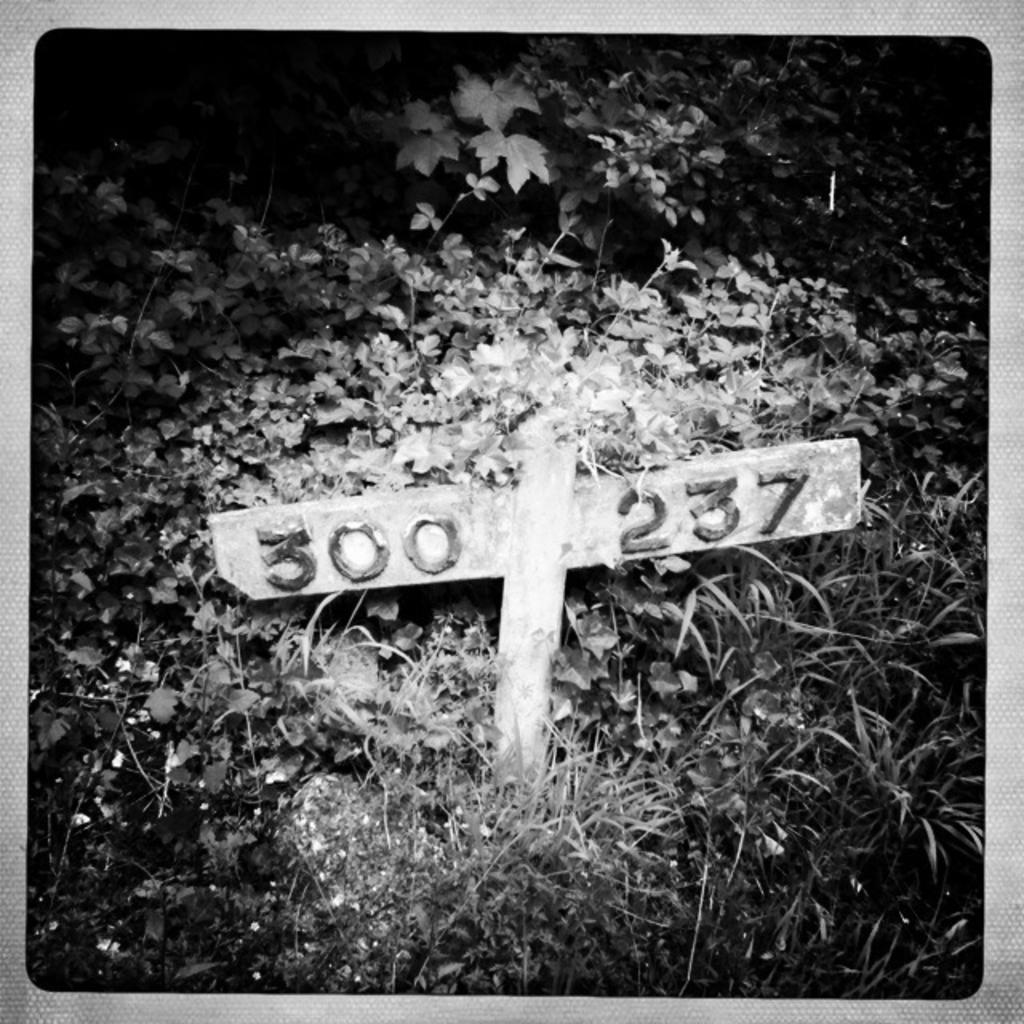<image>
Write a terse but informative summary of the picture. A grave surrounded by grass and leaves is marked 300 237 